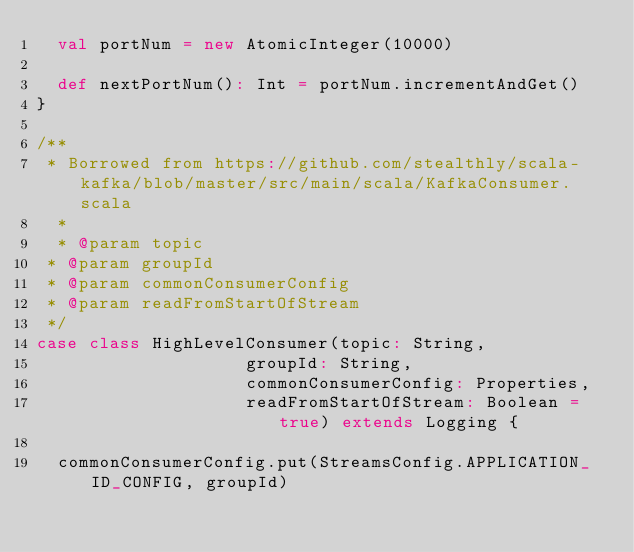Convert code to text. <code><loc_0><loc_0><loc_500><loc_500><_Scala_>  val portNum = new AtomicInteger(10000)
  
  def nextPortNum(): Int = portNum.incrementAndGet()
}

/**
 * Borrowed from https://github.com/stealthly/scala-kafka/blob/master/src/main/scala/KafkaConsumer.scala
  *
  * @param topic
 * @param groupId
 * @param commonConsumerConfig
 * @param readFromStartOfStream
 */
case class HighLevelConsumer(topic: String,
                    groupId: String,
                    commonConsumerConfig: Properties,
                    readFromStartOfStream: Boolean = true) extends Logging {

  commonConsumerConfig.put(StreamsConfig.APPLICATION_ID_CONFIG, groupId)</code> 